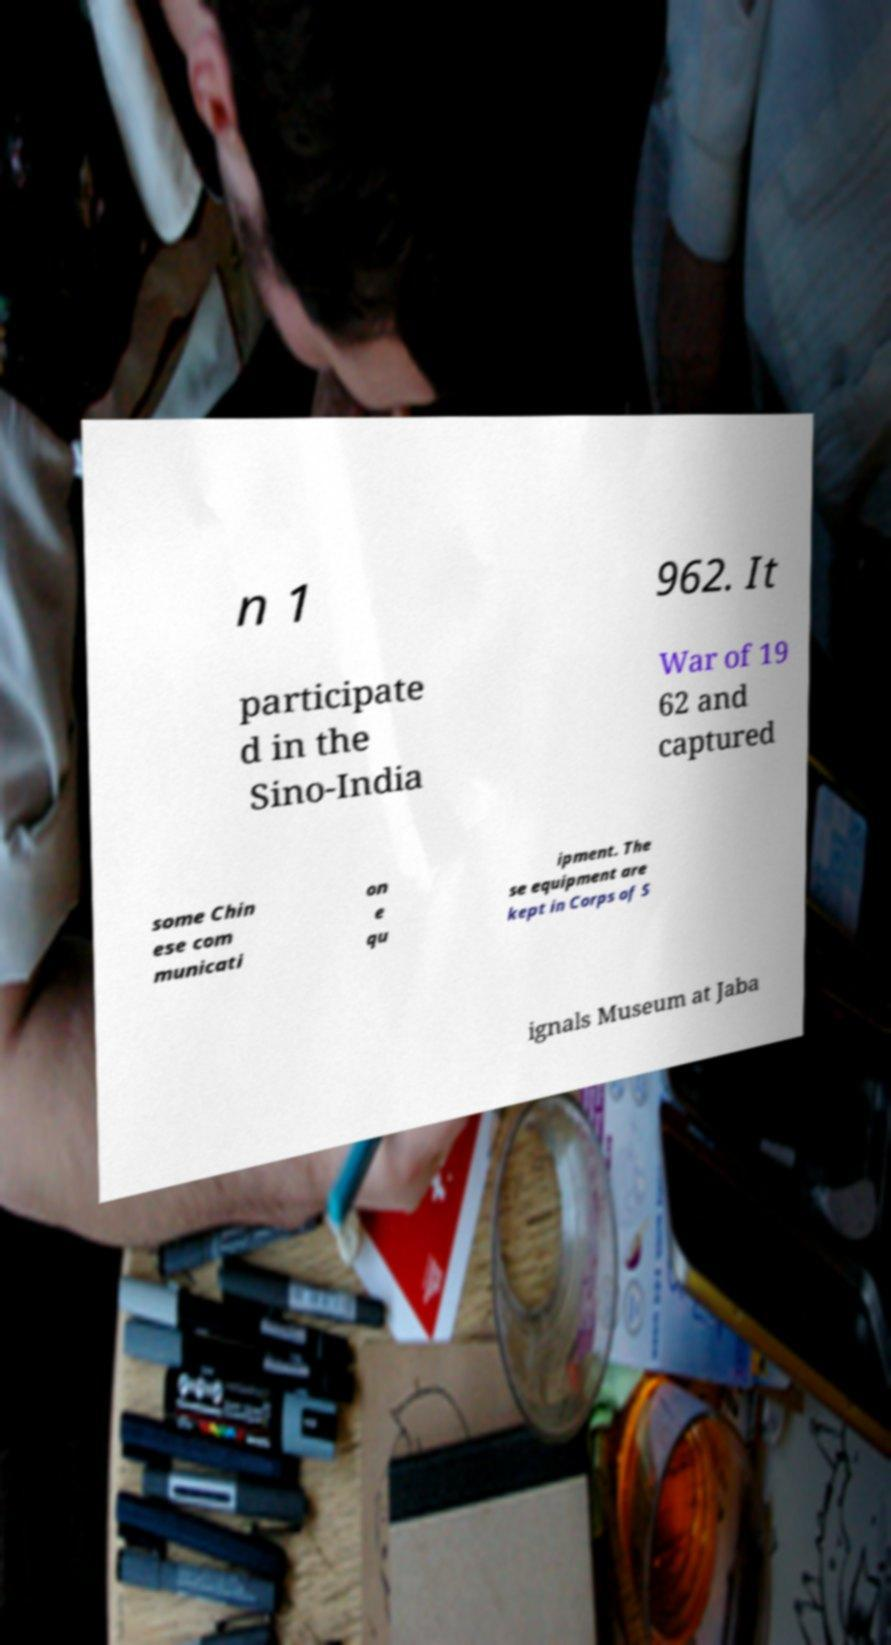For documentation purposes, I need the text within this image transcribed. Could you provide that? n 1 962. It participate d in the Sino-India War of 19 62 and captured some Chin ese com municati on e qu ipment. The se equipment are kept in Corps of S ignals Museum at Jaba 